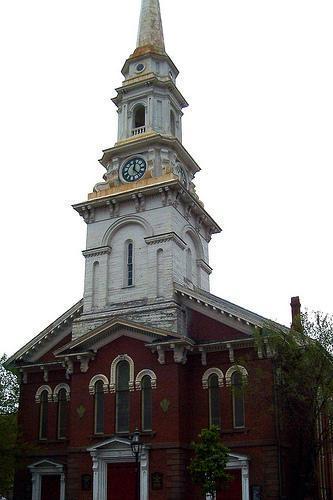How many clock faces are there?
Give a very brief answer. 2. 